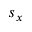Convert formula to latex. <formula><loc_0><loc_0><loc_500><loc_500>s _ { x }</formula> 